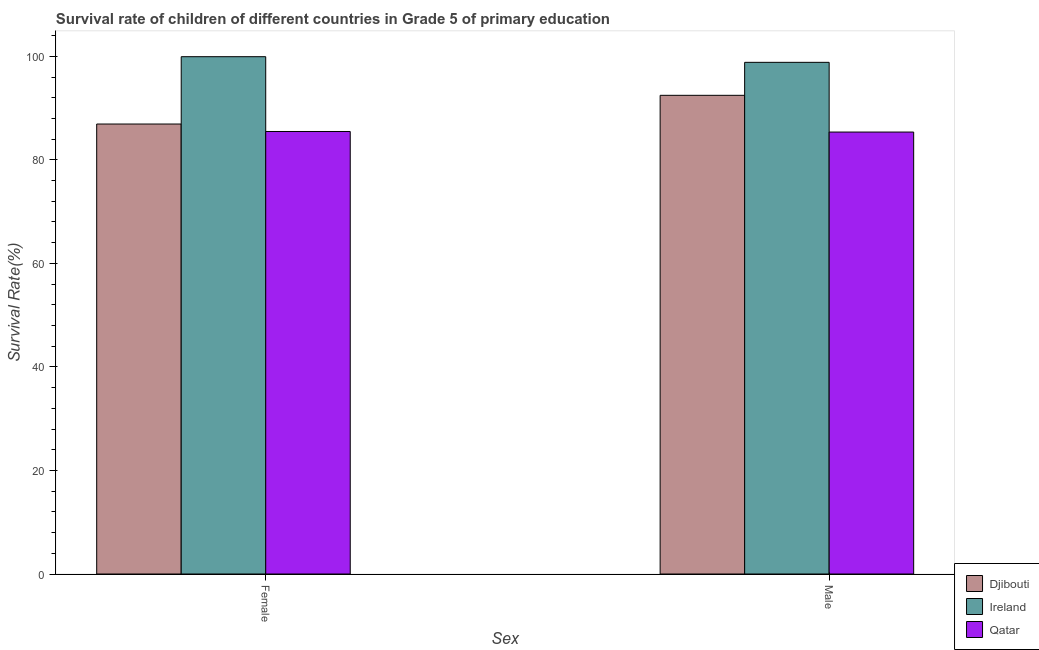How many different coloured bars are there?
Offer a very short reply. 3. How many groups of bars are there?
Keep it short and to the point. 2. Are the number of bars per tick equal to the number of legend labels?
Offer a very short reply. Yes. How many bars are there on the 2nd tick from the right?
Offer a terse response. 3. What is the survival rate of female students in primary education in Djibouti?
Make the answer very short. 86.92. Across all countries, what is the maximum survival rate of female students in primary education?
Offer a very short reply. 99.93. Across all countries, what is the minimum survival rate of female students in primary education?
Your answer should be compact. 85.48. In which country was the survival rate of male students in primary education maximum?
Your answer should be compact. Ireland. In which country was the survival rate of female students in primary education minimum?
Provide a succinct answer. Qatar. What is the total survival rate of female students in primary education in the graph?
Give a very brief answer. 272.34. What is the difference between the survival rate of male students in primary education in Ireland and that in Qatar?
Offer a very short reply. 13.47. What is the difference between the survival rate of female students in primary education in Djibouti and the survival rate of male students in primary education in Qatar?
Your answer should be very brief. 1.55. What is the average survival rate of male students in primary education per country?
Give a very brief answer. 92.23. What is the difference between the survival rate of male students in primary education and survival rate of female students in primary education in Ireland?
Offer a very short reply. -1.09. What is the ratio of the survival rate of male students in primary education in Ireland to that in Qatar?
Your response must be concise. 1.16. In how many countries, is the survival rate of male students in primary education greater than the average survival rate of male students in primary education taken over all countries?
Keep it short and to the point. 2. What does the 3rd bar from the left in Female represents?
Offer a terse response. Qatar. What does the 1st bar from the right in Female represents?
Offer a very short reply. Qatar. How many bars are there?
Keep it short and to the point. 6. Does the graph contain any zero values?
Your answer should be very brief. No. Where does the legend appear in the graph?
Your answer should be very brief. Bottom right. How are the legend labels stacked?
Your response must be concise. Vertical. What is the title of the graph?
Your answer should be compact. Survival rate of children of different countries in Grade 5 of primary education. Does "Oman" appear as one of the legend labels in the graph?
Provide a short and direct response. No. What is the label or title of the X-axis?
Offer a terse response. Sex. What is the label or title of the Y-axis?
Your response must be concise. Survival Rate(%). What is the Survival Rate(%) in Djibouti in Female?
Give a very brief answer. 86.92. What is the Survival Rate(%) in Ireland in Female?
Make the answer very short. 99.93. What is the Survival Rate(%) in Qatar in Female?
Your answer should be very brief. 85.48. What is the Survival Rate(%) of Djibouti in Male?
Your answer should be very brief. 92.47. What is the Survival Rate(%) of Ireland in Male?
Your answer should be compact. 98.84. What is the Survival Rate(%) of Qatar in Male?
Your answer should be compact. 85.37. Across all Sex, what is the maximum Survival Rate(%) of Djibouti?
Ensure brevity in your answer.  92.47. Across all Sex, what is the maximum Survival Rate(%) in Ireland?
Offer a terse response. 99.93. Across all Sex, what is the maximum Survival Rate(%) in Qatar?
Your response must be concise. 85.48. Across all Sex, what is the minimum Survival Rate(%) of Djibouti?
Make the answer very short. 86.92. Across all Sex, what is the minimum Survival Rate(%) of Ireland?
Make the answer very short. 98.84. Across all Sex, what is the minimum Survival Rate(%) of Qatar?
Offer a terse response. 85.37. What is the total Survival Rate(%) in Djibouti in the graph?
Give a very brief answer. 179.39. What is the total Survival Rate(%) of Ireland in the graph?
Provide a short and direct response. 198.77. What is the total Survival Rate(%) of Qatar in the graph?
Offer a terse response. 170.85. What is the difference between the Survival Rate(%) in Djibouti in Female and that in Male?
Ensure brevity in your answer.  -5.54. What is the difference between the Survival Rate(%) in Ireland in Female and that in Male?
Provide a succinct answer. 1.09. What is the difference between the Survival Rate(%) in Qatar in Female and that in Male?
Offer a terse response. 0.11. What is the difference between the Survival Rate(%) in Djibouti in Female and the Survival Rate(%) in Ireland in Male?
Provide a short and direct response. -11.92. What is the difference between the Survival Rate(%) in Djibouti in Female and the Survival Rate(%) in Qatar in Male?
Offer a very short reply. 1.55. What is the difference between the Survival Rate(%) of Ireland in Female and the Survival Rate(%) of Qatar in Male?
Offer a terse response. 14.56. What is the average Survival Rate(%) of Djibouti per Sex?
Your response must be concise. 89.7. What is the average Survival Rate(%) in Ireland per Sex?
Your answer should be very brief. 99.39. What is the average Survival Rate(%) in Qatar per Sex?
Ensure brevity in your answer.  85.43. What is the difference between the Survival Rate(%) in Djibouti and Survival Rate(%) in Ireland in Female?
Provide a short and direct response. -13.01. What is the difference between the Survival Rate(%) of Djibouti and Survival Rate(%) of Qatar in Female?
Your answer should be very brief. 1.44. What is the difference between the Survival Rate(%) of Ireland and Survival Rate(%) of Qatar in Female?
Your answer should be very brief. 14.45. What is the difference between the Survival Rate(%) of Djibouti and Survival Rate(%) of Ireland in Male?
Ensure brevity in your answer.  -6.37. What is the difference between the Survival Rate(%) in Djibouti and Survival Rate(%) in Qatar in Male?
Your answer should be compact. 7.1. What is the difference between the Survival Rate(%) of Ireland and Survival Rate(%) of Qatar in Male?
Your answer should be compact. 13.47. What is the ratio of the Survival Rate(%) of Djibouti in Female to that in Male?
Give a very brief answer. 0.94. What is the difference between the highest and the second highest Survival Rate(%) of Djibouti?
Offer a terse response. 5.54. What is the difference between the highest and the second highest Survival Rate(%) in Ireland?
Make the answer very short. 1.09. What is the difference between the highest and the second highest Survival Rate(%) of Qatar?
Your answer should be very brief. 0.11. What is the difference between the highest and the lowest Survival Rate(%) of Djibouti?
Your answer should be compact. 5.54. What is the difference between the highest and the lowest Survival Rate(%) of Ireland?
Make the answer very short. 1.09. What is the difference between the highest and the lowest Survival Rate(%) in Qatar?
Offer a terse response. 0.11. 